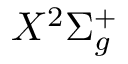<formula> <loc_0><loc_0><loc_500><loc_500>X ^ { 2 } \Sigma _ { g } ^ { + }</formula> 